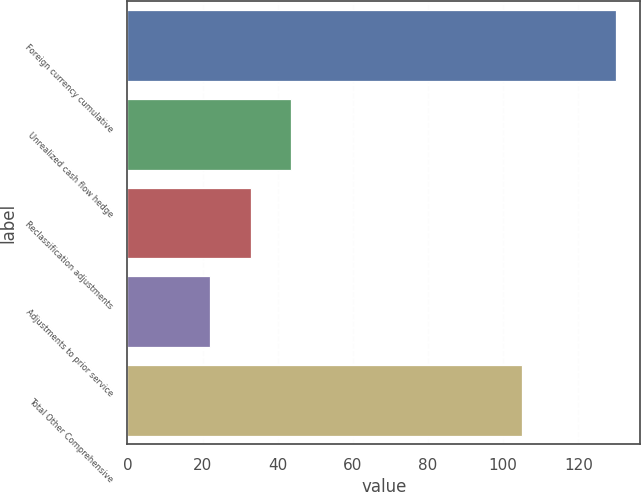Convert chart. <chart><loc_0><loc_0><loc_500><loc_500><bar_chart><fcel>Foreign currency cumulative<fcel>Unrealized cash flow hedge<fcel>Reclassification adjustments<fcel>Adjustments to prior service<fcel>Total Other Comprehensive<nl><fcel>130<fcel>43.6<fcel>32.8<fcel>22<fcel>105<nl></chart> 